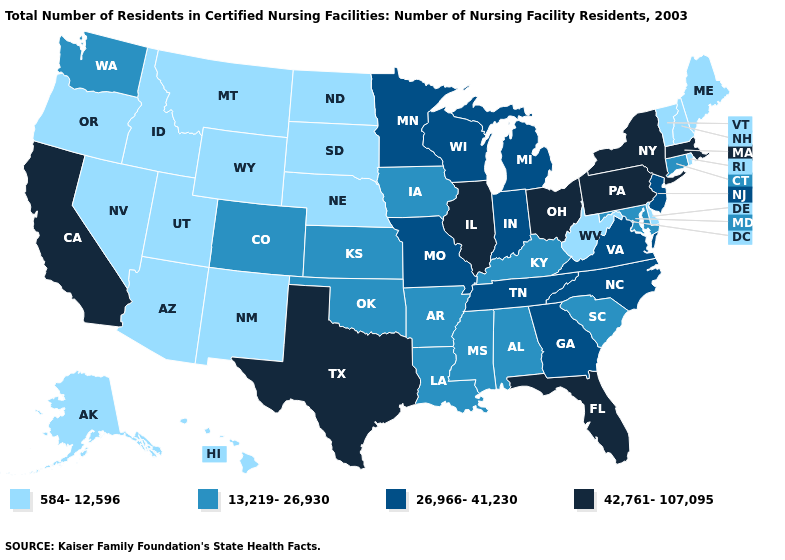What is the value of New Hampshire?
Answer briefly. 584-12,596. How many symbols are there in the legend?
Write a very short answer. 4. Among the states that border West Virginia , which have the highest value?
Answer briefly. Ohio, Pennsylvania. Does Wyoming have the lowest value in the West?
Give a very brief answer. Yes. What is the value of Alaska?
Write a very short answer. 584-12,596. What is the lowest value in the USA?
Be succinct. 584-12,596. Name the states that have a value in the range 584-12,596?
Give a very brief answer. Alaska, Arizona, Delaware, Hawaii, Idaho, Maine, Montana, Nebraska, Nevada, New Hampshire, New Mexico, North Dakota, Oregon, Rhode Island, South Dakota, Utah, Vermont, West Virginia, Wyoming. Name the states that have a value in the range 13,219-26,930?
Quick response, please. Alabama, Arkansas, Colorado, Connecticut, Iowa, Kansas, Kentucky, Louisiana, Maryland, Mississippi, Oklahoma, South Carolina, Washington. Does Nebraska have the highest value in the MidWest?
Keep it brief. No. What is the lowest value in states that border Colorado?
Quick response, please. 584-12,596. Among the states that border Kentucky , which have the highest value?
Give a very brief answer. Illinois, Ohio. Among the states that border Arkansas , does Missouri have the lowest value?
Keep it brief. No. Does Florida have the same value as Hawaii?
Concise answer only. No. What is the value of Washington?
Give a very brief answer. 13,219-26,930. 